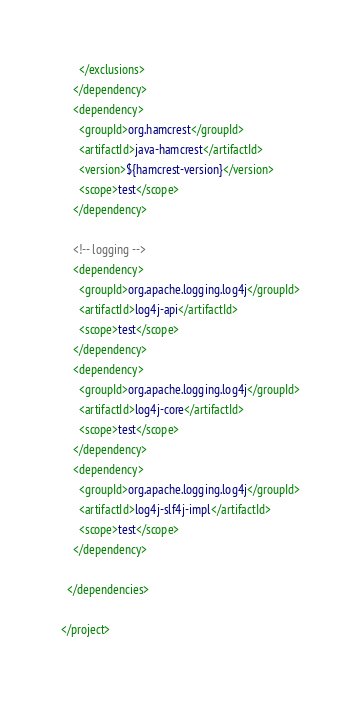<code> <loc_0><loc_0><loc_500><loc_500><_XML_>      </exclusions>
    </dependency>
    <dependency>
      <groupId>org.hamcrest</groupId>
      <artifactId>java-hamcrest</artifactId>
      <version>${hamcrest-version}</version>
      <scope>test</scope>
    </dependency>

    <!-- logging -->   
    <dependency>
      <groupId>org.apache.logging.log4j</groupId>
      <artifactId>log4j-api</artifactId>
      <scope>test</scope>
    </dependency>
    <dependency>
      <groupId>org.apache.logging.log4j</groupId>
      <artifactId>log4j-core</artifactId>
      <scope>test</scope>
    </dependency>
    <dependency>
      <groupId>org.apache.logging.log4j</groupId>
      <artifactId>log4j-slf4j-impl</artifactId>
      <scope>test</scope>
    </dependency>

  </dependencies>

</project>
</code> 